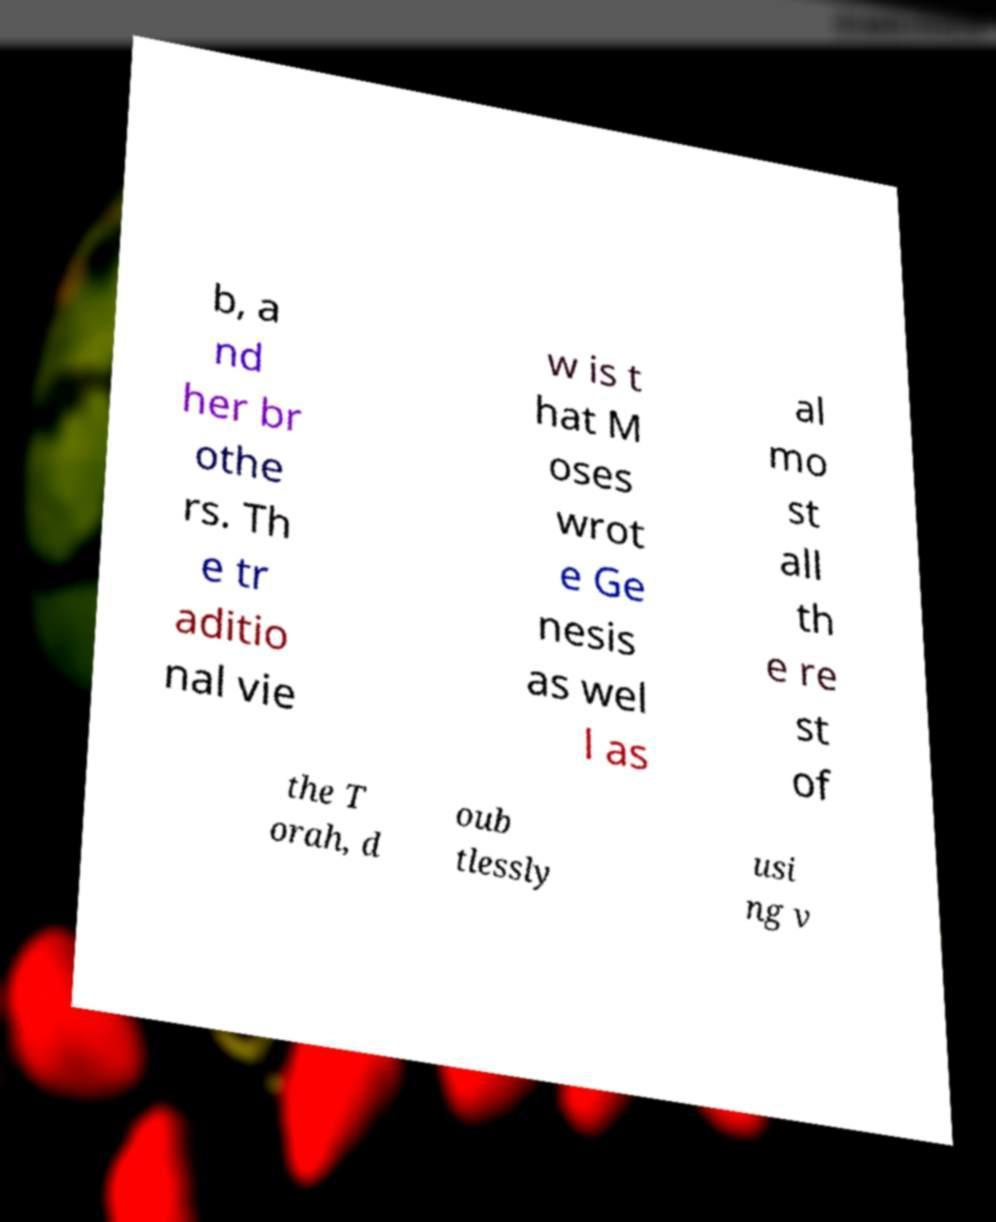There's text embedded in this image that I need extracted. Can you transcribe it verbatim? b, a nd her br othe rs. Th e tr aditio nal vie w is t hat M oses wrot e Ge nesis as wel l as al mo st all th e re st of the T orah, d oub tlessly usi ng v 